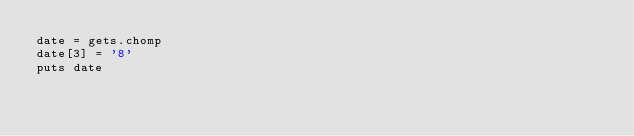<code> <loc_0><loc_0><loc_500><loc_500><_Ruby_>date = gets.chomp
date[3] = '8'
puts date</code> 